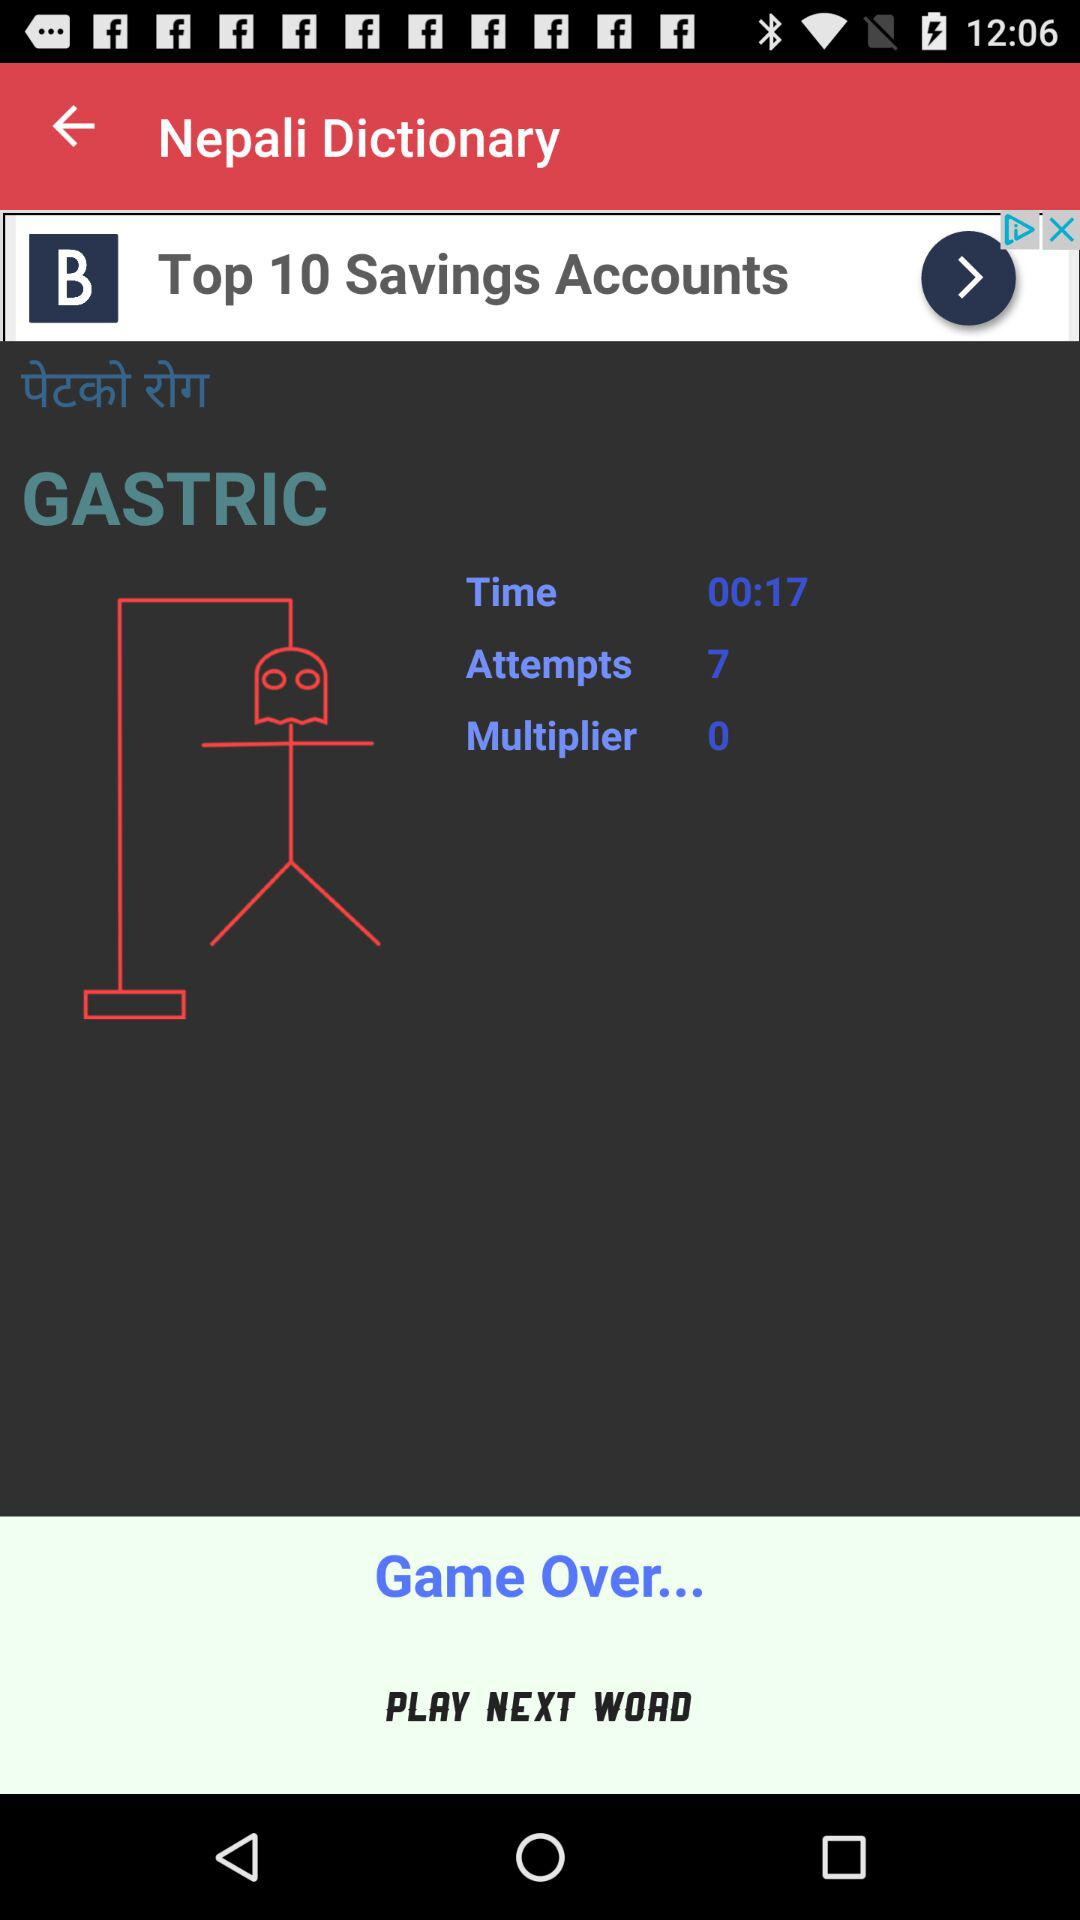How long have I been playing for?
Answer the question using a single word or phrase. 00:17 